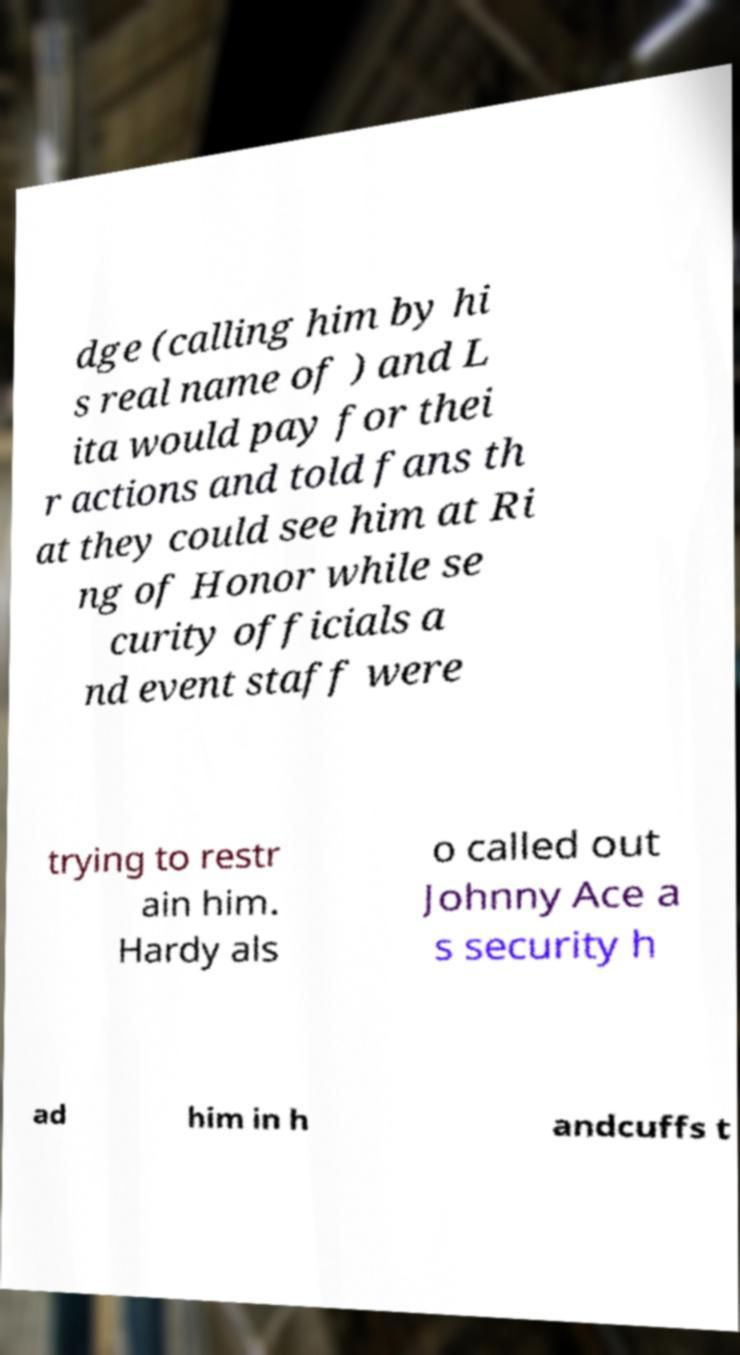What messages or text are displayed in this image? I need them in a readable, typed format. dge (calling him by hi s real name of ) and L ita would pay for thei r actions and told fans th at they could see him at Ri ng of Honor while se curity officials a nd event staff were trying to restr ain him. Hardy als o called out Johnny Ace a s security h ad him in h andcuffs t 